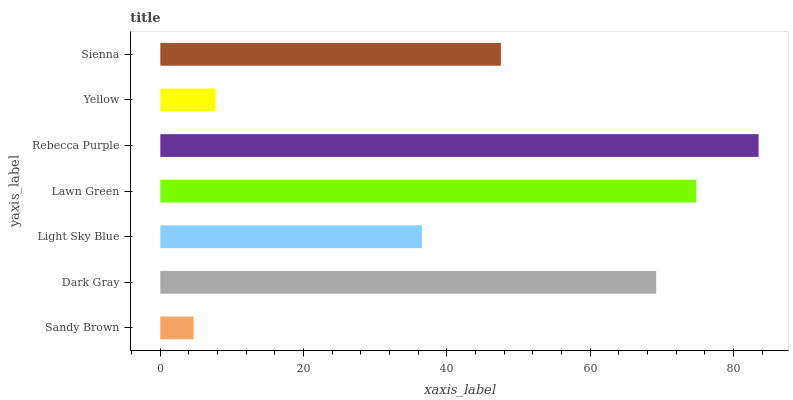Is Sandy Brown the minimum?
Answer yes or no. Yes. Is Rebecca Purple the maximum?
Answer yes or no. Yes. Is Dark Gray the minimum?
Answer yes or no. No. Is Dark Gray the maximum?
Answer yes or no. No. Is Dark Gray greater than Sandy Brown?
Answer yes or no. Yes. Is Sandy Brown less than Dark Gray?
Answer yes or no. Yes. Is Sandy Brown greater than Dark Gray?
Answer yes or no. No. Is Dark Gray less than Sandy Brown?
Answer yes or no. No. Is Sienna the high median?
Answer yes or no. Yes. Is Sienna the low median?
Answer yes or no. Yes. Is Sandy Brown the high median?
Answer yes or no. No. Is Dark Gray the low median?
Answer yes or no. No. 